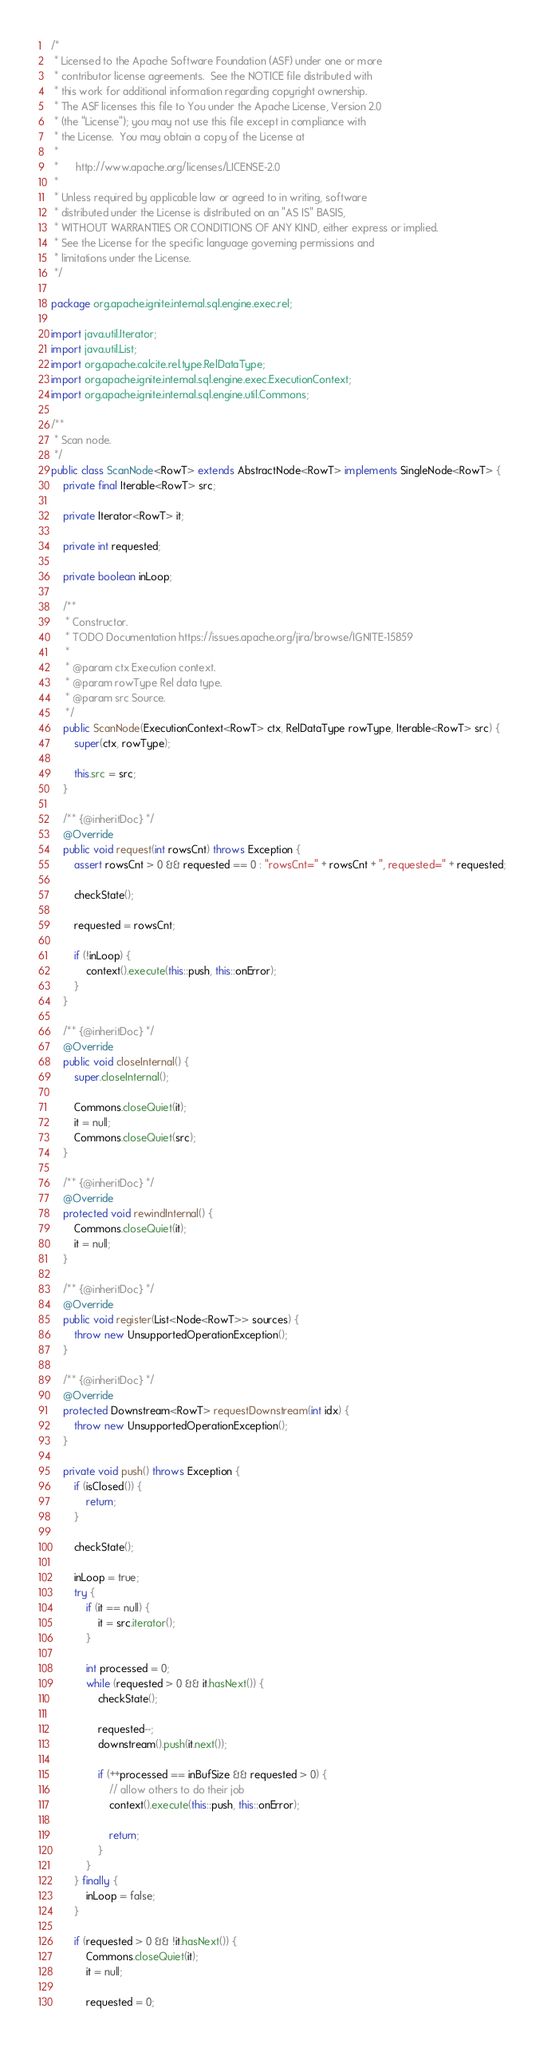Convert code to text. <code><loc_0><loc_0><loc_500><loc_500><_Java_>/*
 * Licensed to the Apache Software Foundation (ASF) under one or more
 * contributor license agreements.  See the NOTICE file distributed with
 * this work for additional information regarding copyright ownership.
 * The ASF licenses this file to You under the Apache License, Version 2.0
 * (the "License"); you may not use this file except in compliance with
 * the License.  You may obtain a copy of the License at
 *
 *      http://www.apache.org/licenses/LICENSE-2.0
 *
 * Unless required by applicable law or agreed to in writing, software
 * distributed under the License is distributed on an "AS IS" BASIS,
 * WITHOUT WARRANTIES OR CONDITIONS OF ANY KIND, either express or implied.
 * See the License for the specific language governing permissions and
 * limitations under the License.
 */

package org.apache.ignite.internal.sql.engine.exec.rel;

import java.util.Iterator;
import java.util.List;
import org.apache.calcite.rel.type.RelDataType;
import org.apache.ignite.internal.sql.engine.exec.ExecutionContext;
import org.apache.ignite.internal.sql.engine.util.Commons;

/**
 * Scan node.
 */
public class ScanNode<RowT> extends AbstractNode<RowT> implements SingleNode<RowT> {
    private final Iterable<RowT> src;

    private Iterator<RowT> it;

    private int requested;

    private boolean inLoop;

    /**
     * Constructor.
     * TODO Documentation https://issues.apache.org/jira/browse/IGNITE-15859
     *
     * @param ctx Execution context.
     * @param rowType Rel data type.
     * @param src Source.
     */
    public ScanNode(ExecutionContext<RowT> ctx, RelDataType rowType, Iterable<RowT> src) {
        super(ctx, rowType);

        this.src = src;
    }

    /** {@inheritDoc} */
    @Override
    public void request(int rowsCnt) throws Exception {
        assert rowsCnt > 0 && requested == 0 : "rowsCnt=" + rowsCnt + ", requested=" + requested;

        checkState();

        requested = rowsCnt;

        if (!inLoop) {
            context().execute(this::push, this::onError);
        }
    }

    /** {@inheritDoc} */
    @Override
    public void closeInternal() {
        super.closeInternal();

        Commons.closeQuiet(it);
        it = null;
        Commons.closeQuiet(src);
    }

    /** {@inheritDoc} */
    @Override
    protected void rewindInternal() {
        Commons.closeQuiet(it);
        it = null;
    }

    /** {@inheritDoc} */
    @Override
    public void register(List<Node<RowT>> sources) {
        throw new UnsupportedOperationException();
    }

    /** {@inheritDoc} */
    @Override
    protected Downstream<RowT> requestDownstream(int idx) {
        throw new UnsupportedOperationException();
    }

    private void push() throws Exception {
        if (isClosed()) {
            return;
        }

        checkState();

        inLoop = true;
        try {
            if (it == null) {
                it = src.iterator();
            }

            int processed = 0;
            while (requested > 0 && it.hasNext()) {
                checkState();

                requested--;
                downstream().push(it.next());

                if (++processed == inBufSize && requested > 0) {
                    // allow others to do their job
                    context().execute(this::push, this::onError);

                    return;
                }
            }
        } finally {
            inLoop = false;
        }

        if (requested > 0 && !it.hasNext()) {
            Commons.closeQuiet(it);
            it = null;

            requested = 0;
</code> 